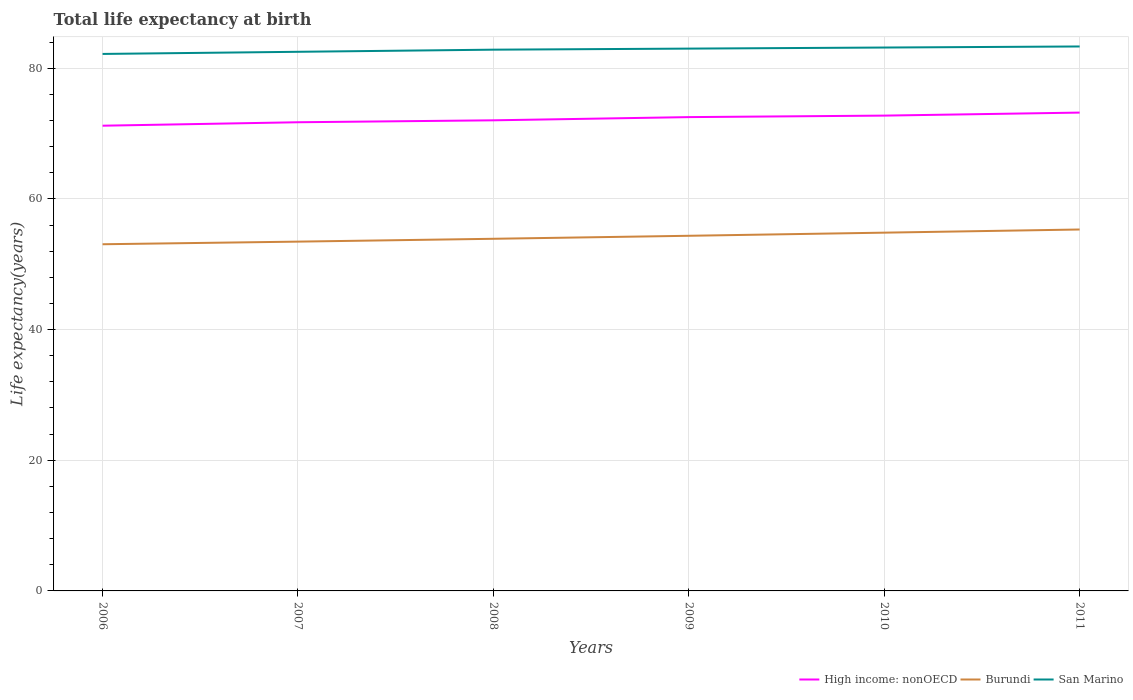Across all years, what is the maximum life expectancy at birth in in San Marino?
Provide a short and direct response. 82.18. In which year was the life expectancy at birth in in San Marino maximum?
Make the answer very short. 2006. What is the total life expectancy at birth in in Burundi in the graph?
Provide a succinct answer. -1.37. What is the difference between the highest and the second highest life expectancy at birth in in High income: nonOECD?
Give a very brief answer. 2.01. What is the difference between the highest and the lowest life expectancy at birth in in High income: nonOECD?
Make the answer very short. 3. How many years are there in the graph?
Make the answer very short. 6. What is the difference between two consecutive major ticks on the Y-axis?
Your answer should be compact. 20. Does the graph contain any zero values?
Provide a succinct answer. No. How are the legend labels stacked?
Your answer should be very brief. Horizontal. What is the title of the graph?
Ensure brevity in your answer.  Total life expectancy at birth. Does "Ethiopia" appear as one of the legend labels in the graph?
Keep it short and to the point. No. What is the label or title of the Y-axis?
Provide a short and direct response. Life expectancy(years). What is the Life expectancy(years) in High income: nonOECD in 2006?
Offer a very short reply. 71.2. What is the Life expectancy(years) in Burundi in 2006?
Offer a very short reply. 53.05. What is the Life expectancy(years) in San Marino in 2006?
Make the answer very short. 82.18. What is the Life expectancy(years) in High income: nonOECD in 2007?
Provide a short and direct response. 71.72. What is the Life expectancy(years) in Burundi in 2007?
Offer a very short reply. 53.46. What is the Life expectancy(years) of San Marino in 2007?
Your answer should be very brief. 82.51. What is the Life expectancy(years) of High income: nonOECD in 2008?
Your answer should be compact. 72.02. What is the Life expectancy(years) of Burundi in 2008?
Give a very brief answer. 53.89. What is the Life expectancy(years) of San Marino in 2008?
Ensure brevity in your answer.  82.83. What is the Life expectancy(years) in High income: nonOECD in 2009?
Provide a short and direct response. 72.51. What is the Life expectancy(years) in Burundi in 2009?
Provide a succinct answer. 54.35. What is the Life expectancy(years) in San Marino in 2009?
Your answer should be very brief. 83. What is the Life expectancy(years) in High income: nonOECD in 2010?
Give a very brief answer. 72.74. What is the Life expectancy(years) in Burundi in 2010?
Provide a short and direct response. 54.83. What is the Life expectancy(years) of San Marino in 2010?
Provide a short and direct response. 83.16. What is the Life expectancy(years) of High income: nonOECD in 2011?
Keep it short and to the point. 73.2. What is the Life expectancy(years) in Burundi in 2011?
Your response must be concise. 55.31. What is the Life expectancy(years) in San Marino in 2011?
Provide a short and direct response. 83.32. Across all years, what is the maximum Life expectancy(years) in High income: nonOECD?
Provide a short and direct response. 73.2. Across all years, what is the maximum Life expectancy(years) of Burundi?
Offer a very short reply. 55.31. Across all years, what is the maximum Life expectancy(years) of San Marino?
Provide a short and direct response. 83.32. Across all years, what is the minimum Life expectancy(years) of High income: nonOECD?
Make the answer very short. 71.2. Across all years, what is the minimum Life expectancy(years) in Burundi?
Your answer should be very brief. 53.05. Across all years, what is the minimum Life expectancy(years) of San Marino?
Make the answer very short. 82.18. What is the total Life expectancy(years) of High income: nonOECD in the graph?
Your answer should be compact. 433.4. What is the total Life expectancy(years) of Burundi in the graph?
Give a very brief answer. 324.89. What is the total Life expectancy(years) of San Marino in the graph?
Offer a very short reply. 497. What is the difference between the Life expectancy(years) in High income: nonOECD in 2006 and that in 2007?
Offer a very short reply. -0.53. What is the difference between the Life expectancy(years) in Burundi in 2006 and that in 2007?
Keep it short and to the point. -0.4. What is the difference between the Life expectancy(years) in San Marino in 2006 and that in 2007?
Offer a very short reply. -0.33. What is the difference between the Life expectancy(years) of High income: nonOECD in 2006 and that in 2008?
Offer a very short reply. -0.82. What is the difference between the Life expectancy(years) of Burundi in 2006 and that in 2008?
Ensure brevity in your answer.  -0.84. What is the difference between the Life expectancy(years) of San Marino in 2006 and that in 2008?
Your answer should be compact. -0.65. What is the difference between the Life expectancy(years) in High income: nonOECD in 2006 and that in 2009?
Provide a succinct answer. -1.32. What is the difference between the Life expectancy(years) in Burundi in 2006 and that in 2009?
Keep it short and to the point. -1.3. What is the difference between the Life expectancy(years) in San Marino in 2006 and that in 2009?
Provide a short and direct response. -0.82. What is the difference between the Life expectancy(years) in High income: nonOECD in 2006 and that in 2010?
Offer a very short reply. -1.55. What is the difference between the Life expectancy(years) in Burundi in 2006 and that in 2010?
Make the answer very short. -1.78. What is the difference between the Life expectancy(years) of San Marino in 2006 and that in 2010?
Give a very brief answer. -0.98. What is the difference between the Life expectancy(years) in High income: nonOECD in 2006 and that in 2011?
Offer a terse response. -2.01. What is the difference between the Life expectancy(years) in Burundi in 2006 and that in 2011?
Make the answer very short. -2.26. What is the difference between the Life expectancy(years) in San Marino in 2006 and that in 2011?
Offer a terse response. -1.14. What is the difference between the Life expectancy(years) in High income: nonOECD in 2007 and that in 2008?
Your response must be concise. -0.3. What is the difference between the Life expectancy(years) of Burundi in 2007 and that in 2008?
Provide a succinct answer. -0.43. What is the difference between the Life expectancy(years) in San Marino in 2007 and that in 2008?
Offer a very short reply. -0.33. What is the difference between the Life expectancy(years) of High income: nonOECD in 2007 and that in 2009?
Keep it short and to the point. -0.79. What is the difference between the Life expectancy(years) of Burundi in 2007 and that in 2009?
Keep it short and to the point. -0.9. What is the difference between the Life expectancy(years) in San Marino in 2007 and that in 2009?
Your answer should be compact. -0.49. What is the difference between the Life expectancy(years) of High income: nonOECD in 2007 and that in 2010?
Make the answer very short. -1.02. What is the difference between the Life expectancy(years) in Burundi in 2007 and that in 2010?
Keep it short and to the point. -1.37. What is the difference between the Life expectancy(years) of San Marino in 2007 and that in 2010?
Ensure brevity in your answer.  -0.65. What is the difference between the Life expectancy(years) in High income: nonOECD in 2007 and that in 2011?
Your answer should be very brief. -1.48. What is the difference between the Life expectancy(years) in Burundi in 2007 and that in 2011?
Ensure brevity in your answer.  -1.86. What is the difference between the Life expectancy(years) in San Marino in 2007 and that in 2011?
Your answer should be compact. -0.82. What is the difference between the Life expectancy(years) of High income: nonOECD in 2008 and that in 2009?
Your response must be concise. -0.49. What is the difference between the Life expectancy(years) of Burundi in 2008 and that in 2009?
Your answer should be very brief. -0.46. What is the difference between the Life expectancy(years) in San Marino in 2008 and that in 2009?
Offer a very short reply. -0.16. What is the difference between the Life expectancy(years) in High income: nonOECD in 2008 and that in 2010?
Ensure brevity in your answer.  -0.72. What is the difference between the Life expectancy(years) in Burundi in 2008 and that in 2010?
Ensure brevity in your answer.  -0.94. What is the difference between the Life expectancy(years) of San Marino in 2008 and that in 2010?
Provide a short and direct response. -0.33. What is the difference between the Life expectancy(years) of High income: nonOECD in 2008 and that in 2011?
Ensure brevity in your answer.  -1.18. What is the difference between the Life expectancy(years) in Burundi in 2008 and that in 2011?
Keep it short and to the point. -1.42. What is the difference between the Life expectancy(years) of San Marino in 2008 and that in 2011?
Your answer should be very brief. -0.49. What is the difference between the Life expectancy(years) of High income: nonOECD in 2009 and that in 2010?
Your answer should be compact. -0.23. What is the difference between the Life expectancy(years) of Burundi in 2009 and that in 2010?
Give a very brief answer. -0.48. What is the difference between the Life expectancy(years) in San Marino in 2009 and that in 2010?
Ensure brevity in your answer.  -0.16. What is the difference between the Life expectancy(years) in High income: nonOECD in 2009 and that in 2011?
Your answer should be compact. -0.69. What is the difference between the Life expectancy(years) in Burundi in 2009 and that in 2011?
Your response must be concise. -0.96. What is the difference between the Life expectancy(years) of San Marino in 2009 and that in 2011?
Offer a very short reply. -0.33. What is the difference between the Life expectancy(years) in High income: nonOECD in 2010 and that in 2011?
Your answer should be very brief. -0.46. What is the difference between the Life expectancy(years) of Burundi in 2010 and that in 2011?
Ensure brevity in your answer.  -0.48. What is the difference between the Life expectancy(years) in San Marino in 2010 and that in 2011?
Keep it short and to the point. -0.16. What is the difference between the Life expectancy(years) of High income: nonOECD in 2006 and the Life expectancy(years) of Burundi in 2007?
Your response must be concise. 17.74. What is the difference between the Life expectancy(years) in High income: nonOECD in 2006 and the Life expectancy(years) in San Marino in 2007?
Your answer should be compact. -11.31. What is the difference between the Life expectancy(years) of Burundi in 2006 and the Life expectancy(years) of San Marino in 2007?
Your response must be concise. -29.45. What is the difference between the Life expectancy(years) in High income: nonOECD in 2006 and the Life expectancy(years) in Burundi in 2008?
Provide a short and direct response. 17.31. What is the difference between the Life expectancy(years) of High income: nonOECD in 2006 and the Life expectancy(years) of San Marino in 2008?
Provide a short and direct response. -11.63. What is the difference between the Life expectancy(years) in Burundi in 2006 and the Life expectancy(years) in San Marino in 2008?
Provide a succinct answer. -29.78. What is the difference between the Life expectancy(years) in High income: nonOECD in 2006 and the Life expectancy(years) in Burundi in 2009?
Your answer should be very brief. 16.85. What is the difference between the Life expectancy(years) of High income: nonOECD in 2006 and the Life expectancy(years) of San Marino in 2009?
Provide a short and direct response. -11.8. What is the difference between the Life expectancy(years) of Burundi in 2006 and the Life expectancy(years) of San Marino in 2009?
Your answer should be compact. -29.94. What is the difference between the Life expectancy(years) in High income: nonOECD in 2006 and the Life expectancy(years) in Burundi in 2010?
Provide a succinct answer. 16.37. What is the difference between the Life expectancy(years) of High income: nonOECD in 2006 and the Life expectancy(years) of San Marino in 2010?
Keep it short and to the point. -11.96. What is the difference between the Life expectancy(years) in Burundi in 2006 and the Life expectancy(years) in San Marino in 2010?
Make the answer very short. -30.11. What is the difference between the Life expectancy(years) in High income: nonOECD in 2006 and the Life expectancy(years) in Burundi in 2011?
Offer a very short reply. 15.88. What is the difference between the Life expectancy(years) in High income: nonOECD in 2006 and the Life expectancy(years) in San Marino in 2011?
Provide a short and direct response. -12.13. What is the difference between the Life expectancy(years) in Burundi in 2006 and the Life expectancy(years) in San Marino in 2011?
Your response must be concise. -30.27. What is the difference between the Life expectancy(years) in High income: nonOECD in 2007 and the Life expectancy(years) in Burundi in 2008?
Your answer should be very brief. 17.83. What is the difference between the Life expectancy(years) of High income: nonOECD in 2007 and the Life expectancy(years) of San Marino in 2008?
Your answer should be very brief. -11.11. What is the difference between the Life expectancy(years) of Burundi in 2007 and the Life expectancy(years) of San Marino in 2008?
Your answer should be very brief. -29.38. What is the difference between the Life expectancy(years) in High income: nonOECD in 2007 and the Life expectancy(years) in Burundi in 2009?
Your response must be concise. 17.37. What is the difference between the Life expectancy(years) of High income: nonOECD in 2007 and the Life expectancy(years) of San Marino in 2009?
Offer a terse response. -11.27. What is the difference between the Life expectancy(years) in Burundi in 2007 and the Life expectancy(years) in San Marino in 2009?
Make the answer very short. -29.54. What is the difference between the Life expectancy(years) of High income: nonOECD in 2007 and the Life expectancy(years) of Burundi in 2010?
Your response must be concise. 16.9. What is the difference between the Life expectancy(years) of High income: nonOECD in 2007 and the Life expectancy(years) of San Marino in 2010?
Provide a short and direct response. -11.44. What is the difference between the Life expectancy(years) of Burundi in 2007 and the Life expectancy(years) of San Marino in 2010?
Make the answer very short. -29.7. What is the difference between the Life expectancy(years) of High income: nonOECD in 2007 and the Life expectancy(years) of Burundi in 2011?
Your answer should be very brief. 16.41. What is the difference between the Life expectancy(years) in High income: nonOECD in 2007 and the Life expectancy(years) in San Marino in 2011?
Offer a terse response. -11.6. What is the difference between the Life expectancy(years) in Burundi in 2007 and the Life expectancy(years) in San Marino in 2011?
Your answer should be very brief. -29.87. What is the difference between the Life expectancy(years) in High income: nonOECD in 2008 and the Life expectancy(years) in Burundi in 2009?
Offer a terse response. 17.67. What is the difference between the Life expectancy(years) in High income: nonOECD in 2008 and the Life expectancy(years) in San Marino in 2009?
Make the answer very short. -10.97. What is the difference between the Life expectancy(years) in Burundi in 2008 and the Life expectancy(years) in San Marino in 2009?
Offer a very short reply. -29.1. What is the difference between the Life expectancy(years) in High income: nonOECD in 2008 and the Life expectancy(years) in Burundi in 2010?
Your answer should be compact. 17.19. What is the difference between the Life expectancy(years) in High income: nonOECD in 2008 and the Life expectancy(years) in San Marino in 2010?
Provide a short and direct response. -11.14. What is the difference between the Life expectancy(years) in Burundi in 2008 and the Life expectancy(years) in San Marino in 2010?
Make the answer very short. -29.27. What is the difference between the Life expectancy(years) of High income: nonOECD in 2008 and the Life expectancy(years) of Burundi in 2011?
Ensure brevity in your answer.  16.71. What is the difference between the Life expectancy(years) in High income: nonOECD in 2008 and the Life expectancy(years) in San Marino in 2011?
Ensure brevity in your answer.  -11.3. What is the difference between the Life expectancy(years) in Burundi in 2008 and the Life expectancy(years) in San Marino in 2011?
Your answer should be compact. -29.43. What is the difference between the Life expectancy(years) of High income: nonOECD in 2009 and the Life expectancy(years) of Burundi in 2010?
Ensure brevity in your answer.  17.68. What is the difference between the Life expectancy(years) of High income: nonOECD in 2009 and the Life expectancy(years) of San Marino in 2010?
Make the answer very short. -10.65. What is the difference between the Life expectancy(years) in Burundi in 2009 and the Life expectancy(years) in San Marino in 2010?
Offer a terse response. -28.81. What is the difference between the Life expectancy(years) of High income: nonOECD in 2009 and the Life expectancy(years) of Burundi in 2011?
Ensure brevity in your answer.  17.2. What is the difference between the Life expectancy(years) in High income: nonOECD in 2009 and the Life expectancy(years) in San Marino in 2011?
Your response must be concise. -10.81. What is the difference between the Life expectancy(years) in Burundi in 2009 and the Life expectancy(years) in San Marino in 2011?
Offer a very short reply. -28.97. What is the difference between the Life expectancy(years) of High income: nonOECD in 2010 and the Life expectancy(years) of Burundi in 2011?
Make the answer very short. 17.43. What is the difference between the Life expectancy(years) in High income: nonOECD in 2010 and the Life expectancy(years) in San Marino in 2011?
Give a very brief answer. -10.58. What is the difference between the Life expectancy(years) in Burundi in 2010 and the Life expectancy(years) in San Marino in 2011?
Offer a terse response. -28.49. What is the average Life expectancy(years) in High income: nonOECD per year?
Your answer should be compact. 72.23. What is the average Life expectancy(years) in Burundi per year?
Your answer should be very brief. 54.15. What is the average Life expectancy(years) in San Marino per year?
Ensure brevity in your answer.  82.83. In the year 2006, what is the difference between the Life expectancy(years) of High income: nonOECD and Life expectancy(years) of Burundi?
Offer a terse response. 18.14. In the year 2006, what is the difference between the Life expectancy(years) of High income: nonOECD and Life expectancy(years) of San Marino?
Your answer should be compact. -10.98. In the year 2006, what is the difference between the Life expectancy(years) in Burundi and Life expectancy(years) in San Marino?
Make the answer very short. -29.13. In the year 2007, what is the difference between the Life expectancy(years) of High income: nonOECD and Life expectancy(years) of Burundi?
Give a very brief answer. 18.27. In the year 2007, what is the difference between the Life expectancy(years) in High income: nonOECD and Life expectancy(years) in San Marino?
Your answer should be compact. -10.78. In the year 2007, what is the difference between the Life expectancy(years) in Burundi and Life expectancy(years) in San Marino?
Provide a succinct answer. -29.05. In the year 2008, what is the difference between the Life expectancy(years) in High income: nonOECD and Life expectancy(years) in Burundi?
Provide a succinct answer. 18.13. In the year 2008, what is the difference between the Life expectancy(years) in High income: nonOECD and Life expectancy(years) in San Marino?
Make the answer very short. -10.81. In the year 2008, what is the difference between the Life expectancy(years) of Burundi and Life expectancy(years) of San Marino?
Your answer should be compact. -28.94. In the year 2009, what is the difference between the Life expectancy(years) in High income: nonOECD and Life expectancy(years) in Burundi?
Give a very brief answer. 18.16. In the year 2009, what is the difference between the Life expectancy(years) in High income: nonOECD and Life expectancy(years) in San Marino?
Give a very brief answer. -10.48. In the year 2009, what is the difference between the Life expectancy(years) in Burundi and Life expectancy(years) in San Marino?
Make the answer very short. -28.64. In the year 2010, what is the difference between the Life expectancy(years) in High income: nonOECD and Life expectancy(years) in Burundi?
Make the answer very short. 17.91. In the year 2010, what is the difference between the Life expectancy(years) of High income: nonOECD and Life expectancy(years) of San Marino?
Offer a terse response. -10.42. In the year 2010, what is the difference between the Life expectancy(years) of Burundi and Life expectancy(years) of San Marino?
Offer a very short reply. -28.33. In the year 2011, what is the difference between the Life expectancy(years) in High income: nonOECD and Life expectancy(years) in Burundi?
Offer a terse response. 17.89. In the year 2011, what is the difference between the Life expectancy(years) in High income: nonOECD and Life expectancy(years) in San Marino?
Offer a terse response. -10.12. In the year 2011, what is the difference between the Life expectancy(years) in Burundi and Life expectancy(years) in San Marino?
Ensure brevity in your answer.  -28.01. What is the ratio of the Life expectancy(years) of High income: nonOECD in 2006 to that in 2008?
Your answer should be compact. 0.99. What is the ratio of the Life expectancy(years) in Burundi in 2006 to that in 2008?
Offer a very short reply. 0.98. What is the ratio of the Life expectancy(years) of High income: nonOECD in 2006 to that in 2009?
Keep it short and to the point. 0.98. What is the ratio of the Life expectancy(years) in Burundi in 2006 to that in 2009?
Give a very brief answer. 0.98. What is the ratio of the Life expectancy(years) of San Marino in 2006 to that in 2009?
Give a very brief answer. 0.99. What is the ratio of the Life expectancy(years) of High income: nonOECD in 2006 to that in 2010?
Your answer should be very brief. 0.98. What is the ratio of the Life expectancy(years) of Burundi in 2006 to that in 2010?
Keep it short and to the point. 0.97. What is the ratio of the Life expectancy(years) in San Marino in 2006 to that in 2010?
Your response must be concise. 0.99. What is the ratio of the Life expectancy(years) of High income: nonOECD in 2006 to that in 2011?
Keep it short and to the point. 0.97. What is the ratio of the Life expectancy(years) in Burundi in 2006 to that in 2011?
Ensure brevity in your answer.  0.96. What is the ratio of the Life expectancy(years) of San Marino in 2006 to that in 2011?
Your response must be concise. 0.99. What is the ratio of the Life expectancy(years) in High income: nonOECD in 2007 to that in 2008?
Offer a very short reply. 1. What is the ratio of the Life expectancy(years) of Burundi in 2007 to that in 2008?
Provide a short and direct response. 0.99. What is the ratio of the Life expectancy(years) in Burundi in 2007 to that in 2009?
Provide a short and direct response. 0.98. What is the ratio of the Life expectancy(years) in High income: nonOECD in 2007 to that in 2010?
Offer a very short reply. 0.99. What is the ratio of the Life expectancy(years) of Burundi in 2007 to that in 2010?
Keep it short and to the point. 0.97. What is the ratio of the Life expectancy(years) in San Marino in 2007 to that in 2010?
Keep it short and to the point. 0.99. What is the ratio of the Life expectancy(years) of High income: nonOECD in 2007 to that in 2011?
Your answer should be compact. 0.98. What is the ratio of the Life expectancy(years) in Burundi in 2007 to that in 2011?
Offer a very short reply. 0.97. What is the ratio of the Life expectancy(years) in San Marino in 2007 to that in 2011?
Give a very brief answer. 0.99. What is the ratio of the Life expectancy(years) of High income: nonOECD in 2008 to that in 2009?
Offer a very short reply. 0.99. What is the ratio of the Life expectancy(years) in High income: nonOECD in 2008 to that in 2010?
Your response must be concise. 0.99. What is the ratio of the Life expectancy(years) of Burundi in 2008 to that in 2010?
Your answer should be very brief. 0.98. What is the ratio of the Life expectancy(years) of High income: nonOECD in 2008 to that in 2011?
Offer a very short reply. 0.98. What is the ratio of the Life expectancy(years) in Burundi in 2008 to that in 2011?
Your answer should be very brief. 0.97. What is the ratio of the Life expectancy(years) in San Marino in 2008 to that in 2011?
Provide a succinct answer. 0.99. What is the ratio of the Life expectancy(years) of Burundi in 2009 to that in 2010?
Offer a very short reply. 0.99. What is the ratio of the Life expectancy(years) of High income: nonOECD in 2009 to that in 2011?
Your answer should be compact. 0.99. What is the ratio of the Life expectancy(years) in Burundi in 2009 to that in 2011?
Your answer should be compact. 0.98. What is the ratio of the Life expectancy(years) of San Marino in 2009 to that in 2011?
Provide a succinct answer. 1. What is the ratio of the Life expectancy(years) of Burundi in 2010 to that in 2011?
Make the answer very short. 0.99. What is the ratio of the Life expectancy(years) in San Marino in 2010 to that in 2011?
Your response must be concise. 1. What is the difference between the highest and the second highest Life expectancy(years) of High income: nonOECD?
Provide a short and direct response. 0.46. What is the difference between the highest and the second highest Life expectancy(years) in Burundi?
Keep it short and to the point. 0.48. What is the difference between the highest and the second highest Life expectancy(years) of San Marino?
Offer a very short reply. 0.16. What is the difference between the highest and the lowest Life expectancy(years) in High income: nonOECD?
Offer a very short reply. 2.01. What is the difference between the highest and the lowest Life expectancy(years) of Burundi?
Ensure brevity in your answer.  2.26. What is the difference between the highest and the lowest Life expectancy(years) in San Marino?
Your response must be concise. 1.14. 